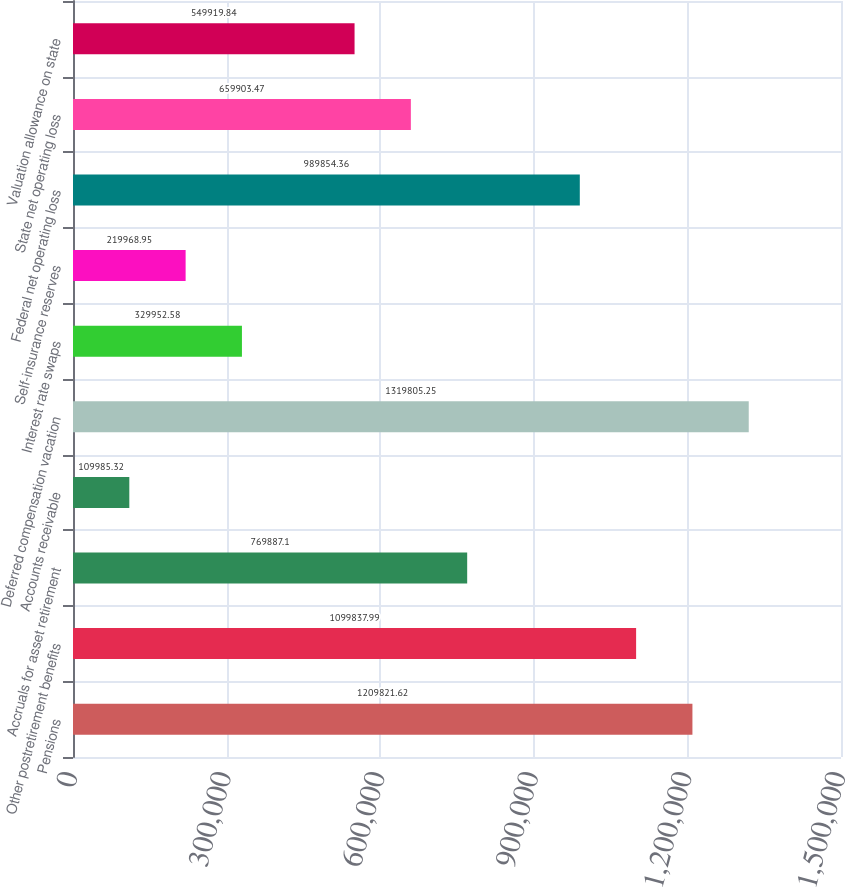<chart> <loc_0><loc_0><loc_500><loc_500><bar_chart><fcel>Pensions<fcel>Other postretirement benefits<fcel>Accruals for asset retirement<fcel>Accounts receivable<fcel>Deferred compensation vacation<fcel>Interest rate swaps<fcel>Self-insurance reserves<fcel>Federal net operating loss<fcel>State net operating loss<fcel>Valuation allowance on state<nl><fcel>1.20982e+06<fcel>1.09984e+06<fcel>769887<fcel>109985<fcel>1.31981e+06<fcel>329953<fcel>219969<fcel>989854<fcel>659903<fcel>549920<nl></chart> 